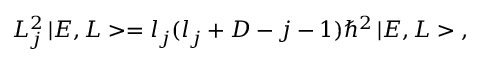<formula> <loc_0><loc_0><loc_500><loc_500>L _ { j } ^ { 2 } \, | E , L > = l _ { j } ( l _ { j } + D - j - 1 ) \hbar { ^ } { 2 } \, | E , L > \, ,</formula> 